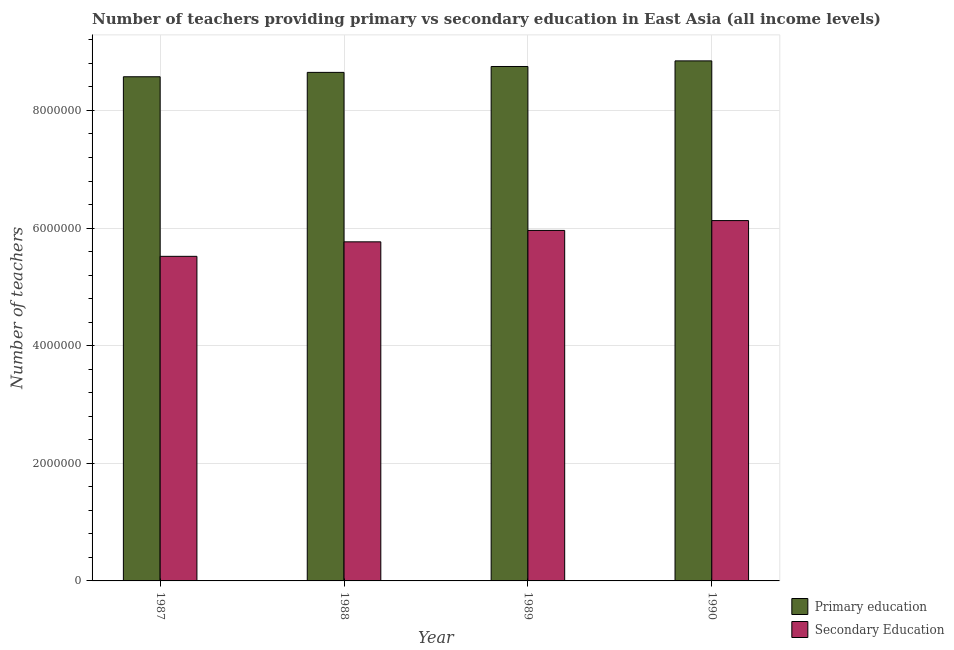How many different coloured bars are there?
Provide a short and direct response. 2. Are the number of bars per tick equal to the number of legend labels?
Offer a very short reply. Yes. In how many cases, is the number of bars for a given year not equal to the number of legend labels?
Ensure brevity in your answer.  0. What is the number of primary teachers in 1990?
Keep it short and to the point. 8.84e+06. Across all years, what is the maximum number of primary teachers?
Your answer should be very brief. 8.84e+06. Across all years, what is the minimum number of primary teachers?
Your answer should be very brief. 8.57e+06. In which year was the number of primary teachers maximum?
Your answer should be very brief. 1990. What is the total number of secondary teachers in the graph?
Offer a very short reply. 2.34e+07. What is the difference between the number of secondary teachers in 1987 and that in 1990?
Provide a succinct answer. -6.08e+05. What is the difference between the number of secondary teachers in 1990 and the number of primary teachers in 1987?
Give a very brief answer. 6.08e+05. What is the average number of secondary teachers per year?
Keep it short and to the point. 5.84e+06. In how many years, is the number of secondary teachers greater than 2800000?
Your answer should be compact. 4. What is the ratio of the number of secondary teachers in 1988 to that in 1990?
Offer a terse response. 0.94. What is the difference between the highest and the second highest number of secondary teachers?
Keep it short and to the point. 1.67e+05. What is the difference between the highest and the lowest number of secondary teachers?
Your answer should be compact. 6.08e+05. Is the sum of the number of secondary teachers in 1987 and 1988 greater than the maximum number of primary teachers across all years?
Offer a very short reply. Yes. What does the 1st bar from the left in 1990 represents?
Keep it short and to the point. Primary education. Are all the bars in the graph horizontal?
Offer a very short reply. No. Are the values on the major ticks of Y-axis written in scientific E-notation?
Keep it short and to the point. No. Does the graph contain any zero values?
Your answer should be compact. No. Does the graph contain grids?
Give a very brief answer. Yes. How many legend labels are there?
Ensure brevity in your answer.  2. How are the legend labels stacked?
Keep it short and to the point. Vertical. What is the title of the graph?
Offer a very short reply. Number of teachers providing primary vs secondary education in East Asia (all income levels). What is the label or title of the X-axis?
Your response must be concise. Year. What is the label or title of the Y-axis?
Offer a terse response. Number of teachers. What is the Number of teachers in Primary education in 1987?
Offer a very short reply. 8.57e+06. What is the Number of teachers in Secondary Education in 1987?
Your answer should be very brief. 5.52e+06. What is the Number of teachers of Primary education in 1988?
Your response must be concise. 8.65e+06. What is the Number of teachers of Secondary Education in 1988?
Ensure brevity in your answer.  5.77e+06. What is the Number of teachers in Primary education in 1989?
Ensure brevity in your answer.  8.75e+06. What is the Number of teachers in Secondary Education in 1989?
Offer a terse response. 5.96e+06. What is the Number of teachers of Primary education in 1990?
Keep it short and to the point. 8.84e+06. What is the Number of teachers of Secondary Education in 1990?
Your answer should be very brief. 6.13e+06. Across all years, what is the maximum Number of teachers of Primary education?
Give a very brief answer. 8.84e+06. Across all years, what is the maximum Number of teachers in Secondary Education?
Give a very brief answer. 6.13e+06. Across all years, what is the minimum Number of teachers of Primary education?
Your answer should be compact. 8.57e+06. Across all years, what is the minimum Number of teachers in Secondary Education?
Your answer should be very brief. 5.52e+06. What is the total Number of teachers of Primary education in the graph?
Give a very brief answer. 3.48e+07. What is the total Number of teachers of Secondary Education in the graph?
Give a very brief answer. 2.34e+07. What is the difference between the Number of teachers in Primary education in 1987 and that in 1988?
Your response must be concise. -7.43e+04. What is the difference between the Number of teachers of Secondary Education in 1987 and that in 1988?
Give a very brief answer. -2.47e+05. What is the difference between the Number of teachers in Primary education in 1987 and that in 1989?
Give a very brief answer. -1.74e+05. What is the difference between the Number of teachers of Secondary Education in 1987 and that in 1989?
Make the answer very short. -4.41e+05. What is the difference between the Number of teachers in Primary education in 1987 and that in 1990?
Your answer should be very brief. -2.70e+05. What is the difference between the Number of teachers in Secondary Education in 1987 and that in 1990?
Keep it short and to the point. -6.08e+05. What is the difference between the Number of teachers of Primary education in 1988 and that in 1989?
Offer a very short reply. -1.00e+05. What is the difference between the Number of teachers in Secondary Education in 1988 and that in 1989?
Offer a terse response. -1.94e+05. What is the difference between the Number of teachers in Primary education in 1988 and that in 1990?
Give a very brief answer. -1.96e+05. What is the difference between the Number of teachers of Secondary Education in 1988 and that in 1990?
Offer a terse response. -3.61e+05. What is the difference between the Number of teachers in Primary education in 1989 and that in 1990?
Make the answer very short. -9.56e+04. What is the difference between the Number of teachers in Secondary Education in 1989 and that in 1990?
Ensure brevity in your answer.  -1.67e+05. What is the difference between the Number of teachers of Primary education in 1987 and the Number of teachers of Secondary Education in 1988?
Your response must be concise. 2.81e+06. What is the difference between the Number of teachers in Primary education in 1987 and the Number of teachers in Secondary Education in 1989?
Ensure brevity in your answer.  2.61e+06. What is the difference between the Number of teachers in Primary education in 1987 and the Number of teachers in Secondary Education in 1990?
Your answer should be compact. 2.45e+06. What is the difference between the Number of teachers of Primary education in 1988 and the Number of teachers of Secondary Education in 1989?
Your answer should be compact. 2.69e+06. What is the difference between the Number of teachers of Primary education in 1988 and the Number of teachers of Secondary Education in 1990?
Your response must be concise. 2.52e+06. What is the difference between the Number of teachers in Primary education in 1989 and the Number of teachers in Secondary Education in 1990?
Ensure brevity in your answer.  2.62e+06. What is the average Number of teachers in Primary education per year?
Give a very brief answer. 8.70e+06. What is the average Number of teachers of Secondary Education per year?
Keep it short and to the point. 5.84e+06. In the year 1987, what is the difference between the Number of teachers of Primary education and Number of teachers of Secondary Education?
Offer a very short reply. 3.05e+06. In the year 1988, what is the difference between the Number of teachers in Primary education and Number of teachers in Secondary Education?
Your response must be concise. 2.88e+06. In the year 1989, what is the difference between the Number of teachers of Primary education and Number of teachers of Secondary Education?
Keep it short and to the point. 2.79e+06. In the year 1990, what is the difference between the Number of teachers in Primary education and Number of teachers in Secondary Education?
Your answer should be very brief. 2.72e+06. What is the ratio of the Number of teachers in Primary education in 1987 to that in 1988?
Your response must be concise. 0.99. What is the ratio of the Number of teachers in Secondary Education in 1987 to that in 1988?
Your answer should be compact. 0.96. What is the ratio of the Number of teachers in Primary education in 1987 to that in 1989?
Provide a succinct answer. 0.98. What is the ratio of the Number of teachers of Secondary Education in 1987 to that in 1989?
Keep it short and to the point. 0.93. What is the ratio of the Number of teachers of Primary education in 1987 to that in 1990?
Give a very brief answer. 0.97. What is the ratio of the Number of teachers of Secondary Education in 1987 to that in 1990?
Make the answer very short. 0.9. What is the ratio of the Number of teachers in Primary education in 1988 to that in 1989?
Your answer should be very brief. 0.99. What is the ratio of the Number of teachers in Secondary Education in 1988 to that in 1989?
Keep it short and to the point. 0.97. What is the ratio of the Number of teachers in Primary education in 1988 to that in 1990?
Provide a succinct answer. 0.98. What is the ratio of the Number of teachers in Secondary Education in 1988 to that in 1990?
Your answer should be compact. 0.94. What is the ratio of the Number of teachers of Primary education in 1989 to that in 1990?
Make the answer very short. 0.99. What is the ratio of the Number of teachers of Secondary Education in 1989 to that in 1990?
Ensure brevity in your answer.  0.97. What is the difference between the highest and the second highest Number of teachers in Primary education?
Your answer should be very brief. 9.56e+04. What is the difference between the highest and the second highest Number of teachers in Secondary Education?
Your response must be concise. 1.67e+05. What is the difference between the highest and the lowest Number of teachers in Primary education?
Offer a terse response. 2.70e+05. What is the difference between the highest and the lowest Number of teachers in Secondary Education?
Your answer should be very brief. 6.08e+05. 